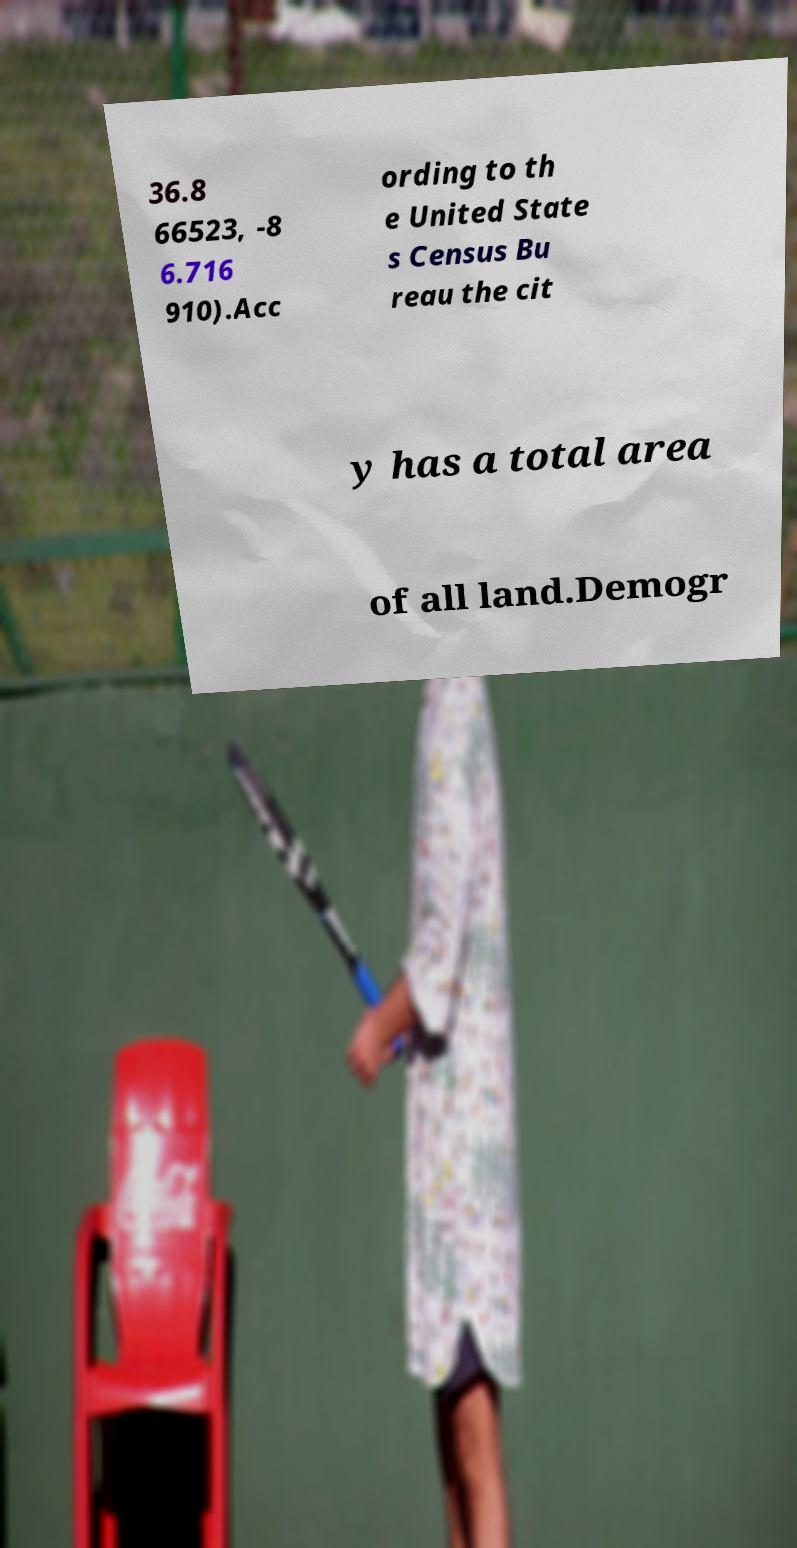What messages or text are displayed in this image? I need them in a readable, typed format. 36.8 66523, -8 6.716 910).Acc ording to th e United State s Census Bu reau the cit y has a total area of all land.Demogr 